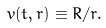Convert formula to latex. <formula><loc_0><loc_0><loc_500><loc_500>v ( t , r ) \equiv R / r .</formula> 